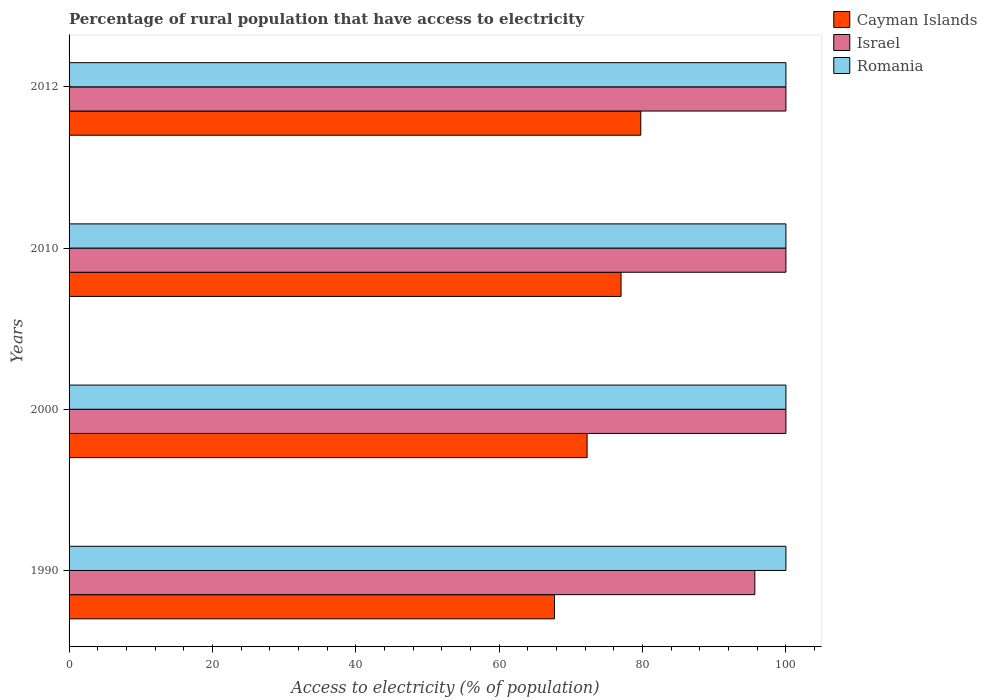Are the number of bars on each tick of the Y-axis equal?
Your response must be concise. Yes. How many bars are there on the 1st tick from the top?
Your answer should be very brief. 3. What is the label of the 2nd group of bars from the top?
Your answer should be compact. 2010. In how many cases, is the number of bars for a given year not equal to the number of legend labels?
Keep it short and to the point. 0. What is the percentage of rural population that have access to electricity in Romania in 2010?
Provide a succinct answer. 100. Across all years, what is the maximum percentage of rural population that have access to electricity in Cayman Islands?
Provide a succinct answer. 79.75. Across all years, what is the minimum percentage of rural population that have access to electricity in Romania?
Offer a terse response. 100. What is the total percentage of rural population that have access to electricity in Israel in the graph?
Provide a short and direct response. 395.66. What is the difference between the percentage of rural population that have access to electricity in Cayman Islands in 1990 and the percentage of rural population that have access to electricity in Israel in 2012?
Offer a very short reply. -32.29. What is the average percentage of rural population that have access to electricity in Cayman Islands per year?
Your answer should be very brief. 74.18. In the year 1990, what is the difference between the percentage of rural population that have access to electricity in Israel and percentage of rural population that have access to electricity in Cayman Islands?
Provide a short and direct response. 27.95. What is the ratio of the percentage of rural population that have access to electricity in Israel in 1990 to that in 2010?
Give a very brief answer. 0.96. Is the percentage of rural population that have access to electricity in Romania in 2000 less than that in 2012?
Offer a terse response. No. Is the difference between the percentage of rural population that have access to electricity in Israel in 1990 and 2012 greater than the difference between the percentage of rural population that have access to electricity in Cayman Islands in 1990 and 2012?
Your answer should be very brief. Yes. What is the difference between the highest and the second highest percentage of rural population that have access to electricity in Israel?
Offer a very short reply. 0. What is the difference between the highest and the lowest percentage of rural population that have access to electricity in Israel?
Make the answer very short. 4.34. In how many years, is the percentage of rural population that have access to electricity in Israel greater than the average percentage of rural population that have access to electricity in Israel taken over all years?
Your answer should be very brief. 3. Is the sum of the percentage of rural population that have access to electricity in Israel in 2010 and 2012 greater than the maximum percentage of rural population that have access to electricity in Cayman Islands across all years?
Your answer should be very brief. Yes. What does the 3rd bar from the top in 2012 represents?
Provide a succinct answer. Cayman Islands. What does the 3rd bar from the bottom in 1990 represents?
Offer a very short reply. Romania. How many bars are there?
Offer a terse response. 12. Are all the bars in the graph horizontal?
Offer a very short reply. Yes. How many years are there in the graph?
Offer a terse response. 4. Does the graph contain grids?
Make the answer very short. No. How many legend labels are there?
Offer a terse response. 3. How are the legend labels stacked?
Your answer should be compact. Vertical. What is the title of the graph?
Your answer should be very brief. Percentage of rural population that have access to electricity. What is the label or title of the X-axis?
Your answer should be very brief. Access to electricity (% of population). What is the label or title of the Y-axis?
Offer a terse response. Years. What is the Access to electricity (% of population) in Cayman Islands in 1990?
Your response must be concise. 67.71. What is the Access to electricity (% of population) of Israel in 1990?
Ensure brevity in your answer.  95.66. What is the Access to electricity (% of population) of Romania in 1990?
Your answer should be compact. 100. What is the Access to electricity (% of population) in Cayman Islands in 2000?
Your response must be concise. 72.27. What is the Access to electricity (% of population) in Cayman Islands in 2010?
Give a very brief answer. 77. What is the Access to electricity (% of population) of Romania in 2010?
Provide a succinct answer. 100. What is the Access to electricity (% of population) of Cayman Islands in 2012?
Offer a terse response. 79.75. Across all years, what is the maximum Access to electricity (% of population) in Cayman Islands?
Provide a short and direct response. 79.75. Across all years, what is the minimum Access to electricity (% of population) of Cayman Islands?
Provide a succinct answer. 67.71. Across all years, what is the minimum Access to electricity (% of population) of Israel?
Offer a very short reply. 95.66. What is the total Access to electricity (% of population) of Cayman Islands in the graph?
Offer a very short reply. 296.73. What is the total Access to electricity (% of population) in Israel in the graph?
Make the answer very short. 395.66. What is the total Access to electricity (% of population) of Romania in the graph?
Keep it short and to the point. 400. What is the difference between the Access to electricity (% of population) in Cayman Islands in 1990 and that in 2000?
Your response must be concise. -4.55. What is the difference between the Access to electricity (% of population) of Israel in 1990 and that in 2000?
Your response must be concise. -4.34. What is the difference between the Access to electricity (% of population) in Romania in 1990 and that in 2000?
Your answer should be compact. 0. What is the difference between the Access to electricity (% of population) of Cayman Islands in 1990 and that in 2010?
Keep it short and to the point. -9.29. What is the difference between the Access to electricity (% of population) in Israel in 1990 and that in 2010?
Keep it short and to the point. -4.34. What is the difference between the Access to electricity (% of population) in Cayman Islands in 1990 and that in 2012?
Ensure brevity in your answer.  -12.04. What is the difference between the Access to electricity (% of population) in Israel in 1990 and that in 2012?
Your answer should be compact. -4.34. What is the difference between the Access to electricity (% of population) of Romania in 1990 and that in 2012?
Give a very brief answer. 0. What is the difference between the Access to electricity (% of population) of Cayman Islands in 2000 and that in 2010?
Your response must be concise. -4.74. What is the difference between the Access to electricity (% of population) of Israel in 2000 and that in 2010?
Provide a succinct answer. 0. What is the difference between the Access to electricity (% of population) in Cayman Islands in 2000 and that in 2012?
Keep it short and to the point. -7.49. What is the difference between the Access to electricity (% of population) in Romania in 2000 and that in 2012?
Provide a short and direct response. 0. What is the difference between the Access to electricity (% of population) in Cayman Islands in 2010 and that in 2012?
Offer a terse response. -2.75. What is the difference between the Access to electricity (% of population) in Romania in 2010 and that in 2012?
Your answer should be very brief. 0. What is the difference between the Access to electricity (% of population) of Cayman Islands in 1990 and the Access to electricity (% of population) of Israel in 2000?
Offer a terse response. -32.29. What is the difference between the Access to electricity (% of population) in Cayman Islands in 1990 and the Access to electricity (% of population) in Romania in 2000?
Your answer should be compact. -32.29. What is the difference between the Access to electricity (% of population) of Israel in 1990 and the Access to electricity (% of population) of Romania in 2000?
Give a very brief answer. -4.34. What is the difference between the Access to electricity (% of population) in Cayman Islands in 1990 and the Access to electricity (% of population) in Israel in 2010?
Provide a succinct answer. -32.29. What is the difference between the Access to electricity (% of population) of Cayman Islands in 1990 and the Access to electricity (% of population) of Romania in 2010?
Keep it short and to the point. -32.29. What is the difference between the Access to electricity (% of population) in Israel in 1990 and the Access to electricity (% of population) in Romania in 2010?
Your answer should be compact. -4.34. What is the difference between the Access to electricity (% of population) of Cayman Islands in 1990 and the Access to electricity (% of population) of Israel in 2012?
Provide a succinct answer. -32.29. What is the difference between the Access to electricity (% of population) in Cayman Islands in 1990 and the Access to electricity (% of population) in Romania in 2012?
Offer a very short reply. -32.29. What is the difference between the Access to electricity (% of population) in Israel in 1990 and the Access to electricity (% of population) in Romania in 2012?
Give a very brief answer. -4.34. What is the difference between the Access to electricity (% of population) of Cayman Islands in 2000 and the Access to electricity (% of population) of Israel in 2010?
Ensure brevity in your answer.  -27.73. What is the difference between the Access to electricity (% of population) of Cayman Islands in 2000 and the Access to electricity (% of population) of Romania in 2010?
Provide a short and direct response. -27.73. What is the difference between the Access to electricity (% of population) in Cayman Islands in 2000 and the Access to electricity (% of population) in Israel in 2012?
Provide a short and direct response. -27.73. What is the difference between the Access to electricity (% of population) in Cayman Islands in 2000 and the Access to electricity (% of population) in Romania in 2012?
Your answer should be very brief. -27.73. What is the difference between the Access to electricity (% of population) in Israel in 2010 and the Access to electricity (% of population) in Romania in 2012?
Your answer should be compact. 0. What is the average Access to electricity (% of population) in Cayman Islands per year?
Your response must be concise. 74.18. What is the average Access to electricity (% of population) of Israel per year?
Your answer should be very brief. 98.92. In the year 1990, what is the difference between the Access to electricity (% of population) in Cayman Islands and Access to electricity (% of population) in Israel?
Your answer should be very brief. -27.95. In the year 1990, what is the difference between the Access to electricity (% of population) of Cayman Islands and Access to electricity (% of population) of Romania?
Offer a terse response. -32.29. In the year 1990, what is the difference between the Access to electricity (% of population) of Israel and Access to electricity (% of population) of Romania?
Offer a very short reply. -4.34. In the year 2000, what is the difference between the Access to electricity (% of population) of Cayman Islands and Access to electricity (% of population) of Israel?
Your response must be concise. -27.73. In the year 2000, what is the difference between the Access to electricity (% of population) in Cayman Islands and Access to electricity (% of population) in Romania?
Give a very brief answer. -27.73. In the year 2010, what is the difference between the Access to electricity (% of population) in Cayman Islands and Access to electricity (% of population) in Romania?
Make the answer very short. -23. In the year 2012, what is the difference between the Access to electricity (% of population) of Cayman Islands and Access to electricity (% of population) of Israel?
Ensure brevity in your answer.  -20.25. In the year 2012, what is the difference between the Access to electricity (% of population) in Cayman Islands and Access to electricity (% of population) in Romania?
Give a very brief answer. -20.25. What is the ratio of the Access to electricity (% of population) of Cayman Islands in 1990 to that in 2000?
Provide a succinct answer. 0.94. What is the ratio of the Access to electricity (% of population) in Israel in 1990 to that in 2000?
Give a very brief answer. 0.96. What is the ratio of the Access to electricity (% of population) in Cayman Islands in 1990 to that in 2010?
Give a very brief answer. 0.88. What is the ratio of the Access to electricity (% of population) in Israel in 1990 to that in 2010?
Your response must be concise. 0.96. What is the ratio of the Access to electricity (% of population) in Cayman Islands in 1990 to that in 2012?
Provide a short and direct response. 0.85. What is the ratio of the Access to electricity (% of population) in Israel in 1990 to that in 2012?
Make the answer very short. 0.96. What is the ratio of the Access to electricity (% of population) in Cayman Islands in 2000 to that in 2010?
Offer a terse response. 0.94. What is the ratio of the Access to electricity (% of population) of Israel in 2000 to that in 2010?
Give a very brief answer. 1. What is the ratio of the Access to electricity (% of population) of Romania in 2000 to that in 2010?
Give a very brief answer. 1. What is the ratio of the Access to electricity (% of population) in Cayman Islands in 2000 to that in 2012?
Give a very brief answer. 0.91. What is the ratio of the Access to electricity (% of population) of Israel in 2000 to that in 2012?
Your answer should be compact. 1. What is the ratio of the Access to electricity (% of population) in Romania in 2000 to that in 2012?
Offer a terse response. 1. What is the ratio of the Access to electricity (% of population) in Cayman Islands in 2010 to that in 2012?
Provide a short and direct response. 0.97. What is the ratio of the Access to electricity (% of population) in Israel in 2010 to that in 2012?
Your answer should be compact. 1. What is the difference between the highest and the second highest Access to electricity (% of population) in Cayman Islands?
Provide a short and direct response. 2.75. What is the difference between the highest and the second highest Access to electricity (% of population) of Romania?
Provide a succinct answer. 0. What is the difference between the highest and the lowest Access to electricity (% of population) of Cayman Islands?
Offer a terse response. 12.04. What is the difference between the highest and the lowest Access to electricity (% of population) of Israel?
Your answer should be compact. 4.34. 